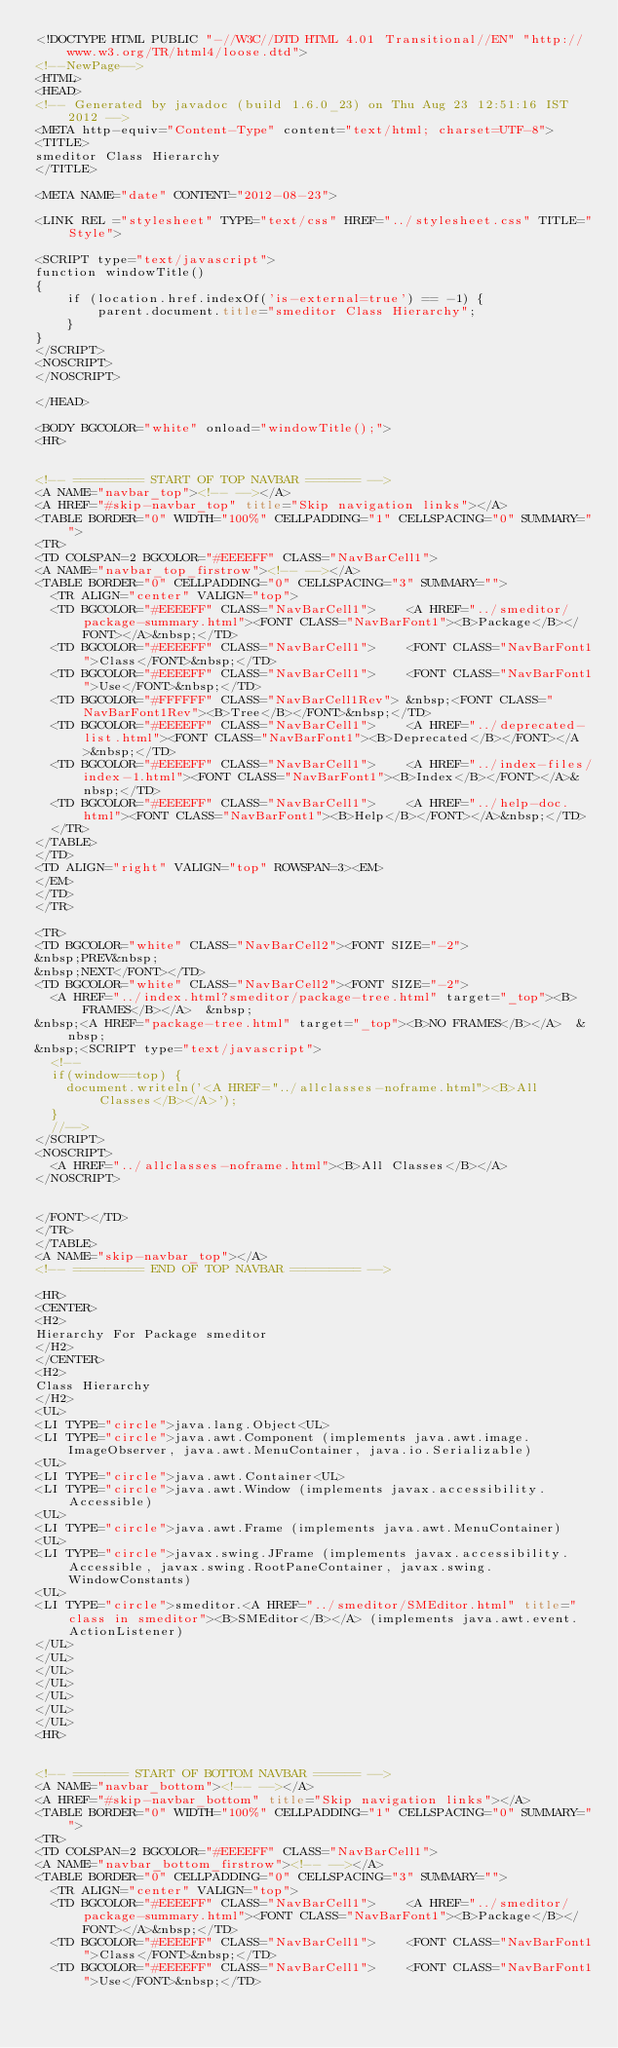<code> <loc_0><loc_0><loc_500><loc_500><_HTML_><!DOCTYPE HTML PUBLIC "-//W3C//DTD HTML 4.01 Transitional//EN" "http://www.w3.org/TR/html4/loose.dtd">
<!--NewPage-->
<HTML>
<HEAD>
<!-- Generated by javadoc (build 1.6.0_23) on Thu Aug 23 12:51:16 IST 2012 -->
<META http-equiv="Content-Type" content="text/html; charset=UTF-8">
<TITLE>
smeditor Class Hierarchy
</TITLE>

<META NAME="date" CONTENT="2012-08-23">

<LINK REL ="stylesheet" TYPE="text/css" HREF="../stylesheet.css" TITLE="Style">

<SCRIPT type="text/javascript">
function windowTitle()
{
    if (location.href.indexOf('is-external=true') == -1) {
        parent.document.title="smeditor Class Hierarchy";
    }
}
</SCRIPT>
<NOSCRIPT>
</NOSCRIPT>

</HEAD>

<BODY BGCOLOR="white" onload="windowTitle();">
<HR>


<!-- ========= START OF TOP NAVBAR ======= -->
<A NAME="navbar_top"><!-- --></A>
<A HREF="#skip-navbar_top" title="Skip navigation links"></A>
<TABLE BORDER="0" WIDTH="100%" CELLPADDING="1" CELLSPACING="0" SUMMARY="">
<TR>
<TD COLSPAN=2 BGCOLOR="#EEEEFF" CLASS="NavBarCell1">
<A NAME="navbar_top_firstrow"><!-- --></A>
<TABLE BORDER="0" CELLPADDING="0" CELLSPACING="3" SUMMARY="">
  <TR ALIGN="center" VALIGN="top">
  <TD BGCOLOR="#EEEEFF" CLASS="NavBarCell1">    <A HREF="../smeditor/package-summary.html"><FONT CLASS="NavBarFont1"><B>Package</B></FONT></A>&nbsp;</TD>
  <TD BGCOLOR="#EEEEFF" CLASS="NavBarCell1">    <FONT CLASS="NavBarFont1">Class</FONT>&nbsp;</TD>
  <TD BGCOLOR="#EEEEFF" CLASS="NavBarCell1">    <FONT CLASS="NavBarFont1">Use</FONT>&nbsp;</TD>
  <TD BGCOLOR="#FFFFFF" CLASS="NavBarCell1Rev"> &nbsp;<FONT CLASS="NavBarFont1Rev"><B>Tree</B></FONT>&nbsp;</TD>
  <TD BGCOLOR="#EEEEFF" CLASS="NavBarCell1">    <A HREF="../deprecated-list.html"><FONT CLASS="NavBarFont1"><B>Deprecated</B></FONT></A>&nbsp;</TD>
  <TD BGCOLOR="#EEEEFF" CLASS="NavBarCell1">    <A HREF="../index-files/index-1.html"><FONT CLASS="NavBarFont1"><B>Index</B></FONT></A>&nbsp;</TD>
  <TD BGCOLOR="#EEEEFF" CLASS="NavBarCell1">    <A HREF="../help-doc.html"><FONT CLASS="NavBarFont1"><B>Help</B></FONT></A>&nbsp;</TD>
  </TR>
</TABLE>
</TD>
<TD ALIGN="right" VALIGN="top" ROWSPAN=3><EM>
</EM>
</TD>
</TR>

<TR>
<TD BGCOLOR="white" CLASS="NavBarCell2"><FONT SIZE="-2">
&nbsp;PREV&nbsp;
&nbsp;NEXT</FONT></TD>
<TD BGCOLOR="white" CLASS="NavBarCell2"><FONT SIZE="-2">
  <A HREF="../index.html?smeditor/package-tree.html" target="_top"><B>FRAMES</B></A>  &nbsp;
&nbsp;<A HREF="package-tree.html" target="_top"><B>NO FRAMES</B></A>  &nbsp;
&nbsp;<SCRIPT type="text/javascript">
  <!--
  if(window==top) {
    document.writeln('<A HREF="../allclasses-noframe.html"><B>All Classes</B></A>');
  }
  //-->
</SCRIPT>
<NOSCRIPT>
  <A HREF="../allclasses-noframe.html"><B>All Classes</B></A>
</NOSCRIPT>


</FONT></TD>
</TR>
</TABLE>
<A NAME="skip-navbar_top"></A>
<!-- ========= END OF TOP NAVBAR ========= -->

<HR>
<CENTER>
<H2>
Hierarchy For Package smeditor
</H2>
</CENTER>
<H2>
Class Hierarchy
</H2>
<UL>
<LI TYPE="circle">java.lang.Object<UL>
<LI TYPE="circle">java.awt.Component (implements java.awt.image.ImageObserver, java.awt.MenuContainer, java.io.Serializable)
<UL>
<LI TYPE="circle">java.awt.Container<UL>
<LI TYPE="circle">java.awt.Window (implements javax.accessibility.Accessible)
<UL>
<LI TYPE="circle">java.awt.Frame (implements java.awt.MenuContainer)
<UL>
<LI TYPE="circle">javax.swing.JFrame (implements javax.accessibility.Accessible, javax.swing.RootPaneContainer, javax.swing.WindowConstants)
<UL>
<LI TYPE="circle">smeditor.<A HREF="../smeditor/SMEditor.html" title="class in smeditor"><B>SMEditor</B></A> (implements java.awt.event.ActionListener)
</UL>
</UL>
</UL>
</UL>
</UL>
</UL>
</UL>
<HR>


<!-- ======= START OF BOTTOM NAVBAR ====== -->
<A NAME="navbar_bottom"><!-- --></A>
<A HREF="#skip-navbar_bottom" title="Skip navigation links"></A>
<TABLE BORDER="0" WIDTH="100%" CELLPADDING="1" CELLSPACING="0" SUMMARY="">
<TR>
<TD COLSPAN=2 BGCOLOR="#EEEEFF" CLASS="NavBarCell1">
<A NAME="navbar_bottom_firstrow"><!-- --></A>
<TABLE BORDER="0" CELLPADDING="0" CELLSPACING="3" SUMMARY="">
  <TR ALIGN="center" VALIGN="top">
  <TD BGCOLOR="#EEEEFF" CLASS="NavBarCell1">    <A HREF="../smeditor/package-summary.html"><FONT CLASS="NavBarFont1"><B>Package</B></FONT></A>&nbsp;</TD>
  <TD BGCOLOR="#EEEEFF" CLASS="NavBarCell1">    <FONT CLASS="NavBarFont1">Class</FONT>&nbsp;</TD>
  <TD BGCOLOR="#EEEEFF" CLASS="NavBarCell1">    <FONT CLASS="NavBarFont1">Use</FONT>&nbsp;</TD></code> 